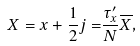<formula> <loc_0><loc_0><loc_500><loc_500>X = x + \frac { 1 } { 2 } { j = } \frac { \tau _ { x } ^ { \prime } } N \overline { X } ,</formula> 